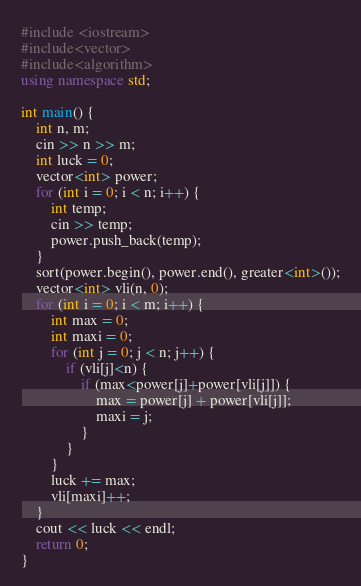<code> <loc_0><loc_0><loc_500><loc_500><_C++_>#include <iostream>
#include<vector>
#include<algorithm>
using namespace std;

int main() {
    int n, m;
    cin >> n >> m;
    int luck = 0;
    vector<int> power;
    for (int i = 0; i < n; i++) {
        int temp;
        cin >> temp;
        power.push_back(temp);
    }
    sort(power.begin(), power.end(), greater<int>());
    vector<int> vli(n, 0);
    for (int i = 0; i < m; i++) {
        int max = 0;
        int maxi = 0;
        for (int j = 0; j < n; j++) {
            if (vli[j]<n) {
                if (max<power[j]+power[vli[j]]) {
                    max = power[j] + power[vli[j]];
                    maxi = j;
                }
            }
        }
        luck += max;
        vli[maxi]++;
    }
    cout << luck << endl;
    return 0;
}</code> 